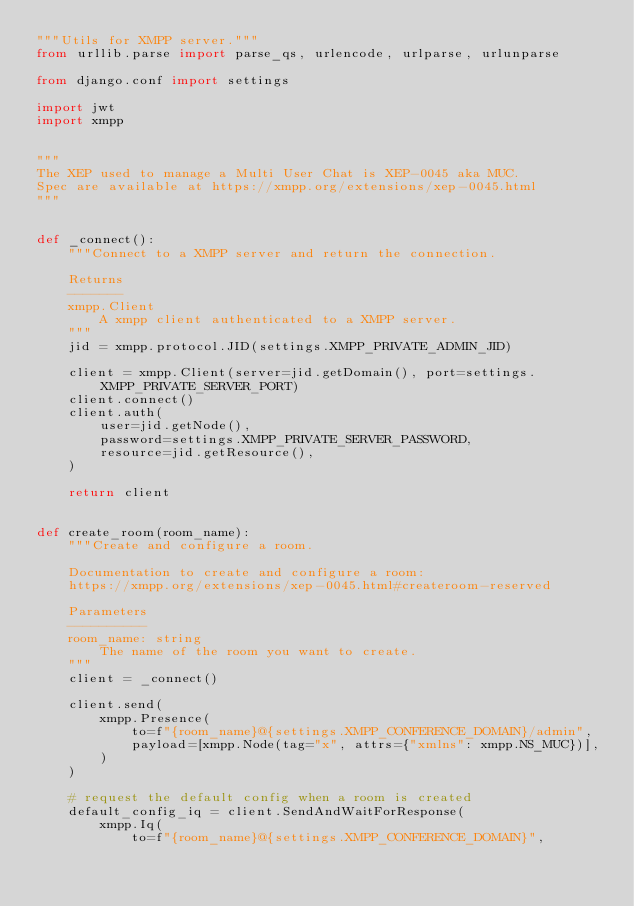Convert code to text. <code><loc_0><loc_0><loc_500><loc_500><_Python_>"""Utils for XMPP server."""
from urllib.parse import parse_qs, urlencode, urlparse, urlunparse

from django.conf import settings

import jwt
import xmpp


"""
The XEP used to manage a Multi User Chat is XEP-0045 aka MUC.
Spec are available at https://xmpp.org/extensions/xep-0045.html
"""


def _connect():
    """Connect to a XMPP server and return the connection.

    Returns
    -------
    xmpp.Client
        A xmpp client authenticated to a XMPP server.
    """
    jid = xmpp.protocol.JID(settings.XMPP_PRIVATE_ADMIN_JID)

    client = xmpp.Client(server=jid.getDomain(), port=settings.XMPP_PRIVATE_SERVER_PORT)
    client.connect()
    client.auth(
        user=jid.getNode(),
        password=settings.XMPP_PRIVATE_SERVER_PASSWORD,
        resource=jid.getResource(),
    )

    return client


def create_room(room_name):
    """Create and configure a room.

    Documentation to create and configure a room:
    https://xmpp.org/extensions/xep-0045.html#createroom-reserved

    Parameters
    ----------
    room_name: string
        The name of the room you want to create.
    """
    client = _connect()

    client.send(
        xmpp.Presence(
            to=f"{room_name}@{settings.XMPP_CONFERENCE_DOMAIN}/admin",
            payload=[xmpp.Node(tag="x", attrs={"xmlns": xmpp.NS_MUC})],
        )
    )

    # request the default config when a room is created
    default_config_iq = client.SendAndWaitForResponse(
        xmpp.Iq(
            to=f"{room_name}@{settings.XMPP_CONFERENCE_DOMAIN}",</code> 